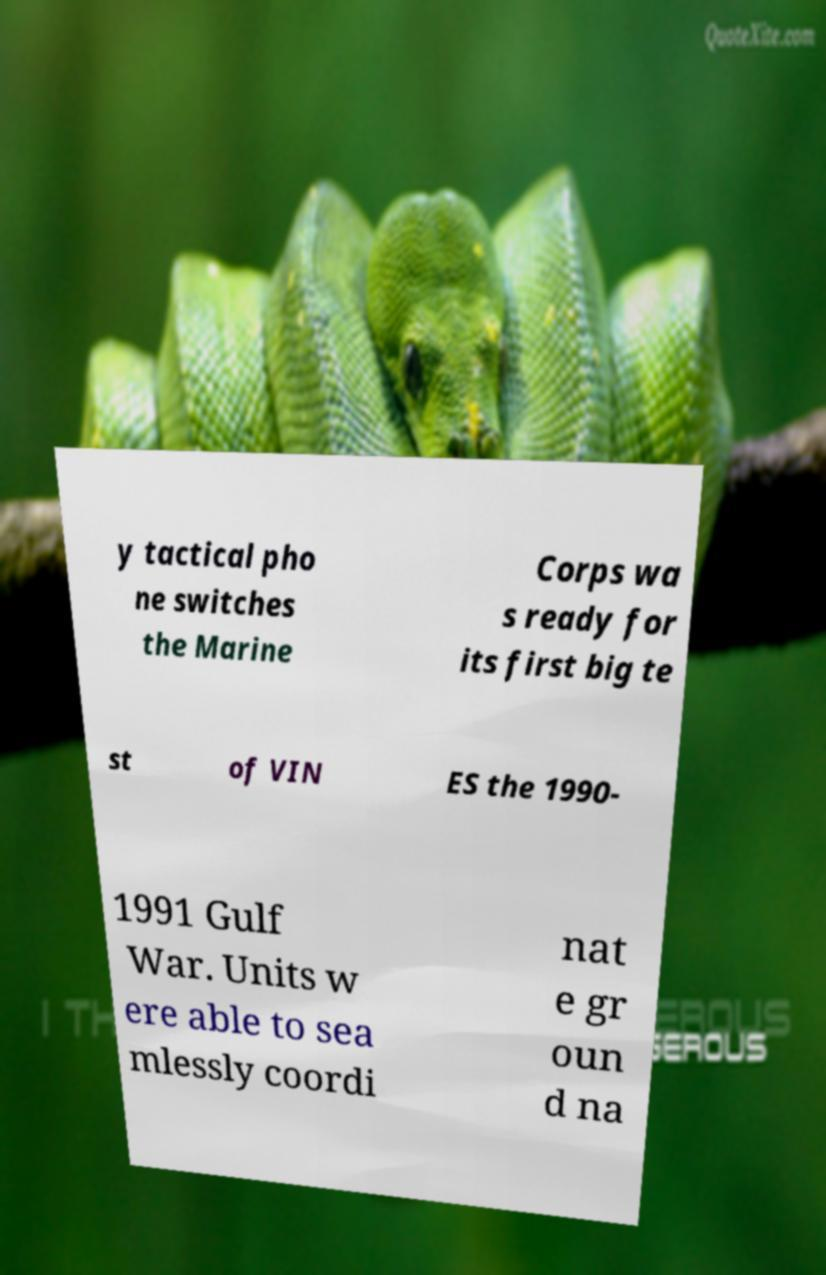There's text embedded in this image that I need extracted. Can you transcribe it verbatim? y tactical pho ne switches the Marine Corps wa s ready for its first big te st of VIN ES the 1990- 1991 Gulf War. Units w ere able to sea mlessly coordi nat e gr oun d na 